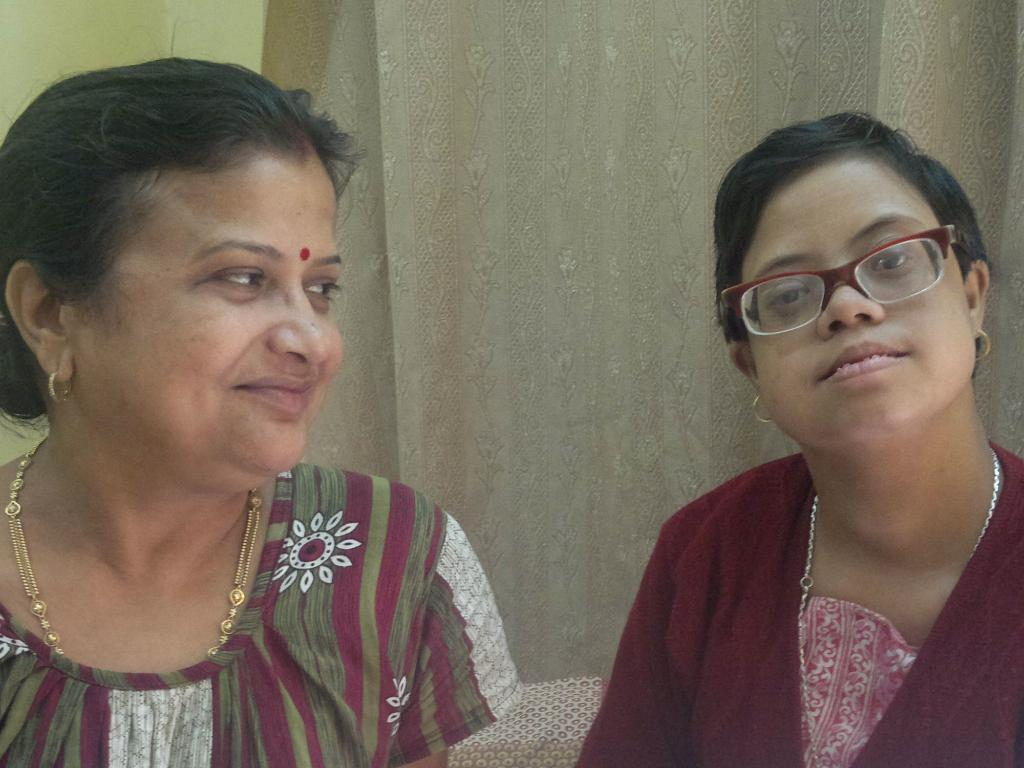How many people are in the image? There are two women in the image. What can be seen in the background of the image? There is a wall and a curtain in the background of the image. What type of quilt is being used to tell a story in the image? There is no quilt or storytelling depicted in the image; it simply shows two women and a background with a wall and curtain. 